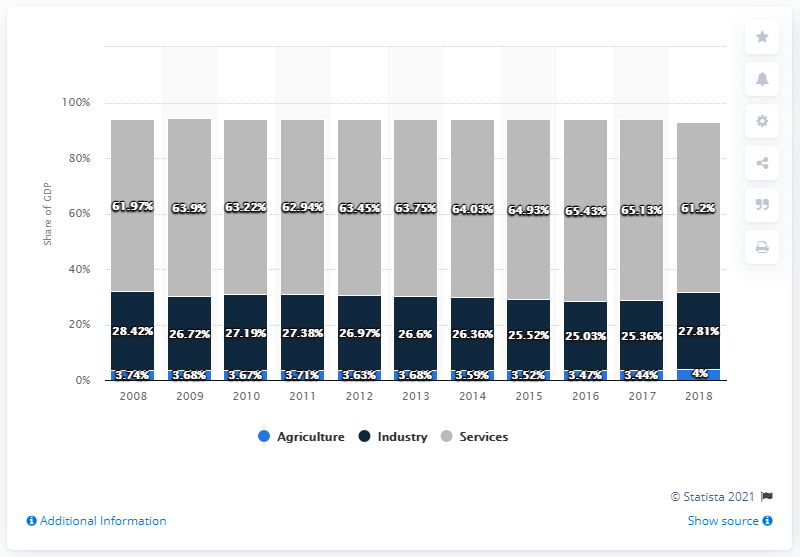Specify some key components in this picture. In 2016, the Gross Domestic Product (GDP) in services was at its highest level. The difference between the maximum Gross Domestic Product (GDP) in Services and the minimum GDP in Industry over the years has been 40.4%. 